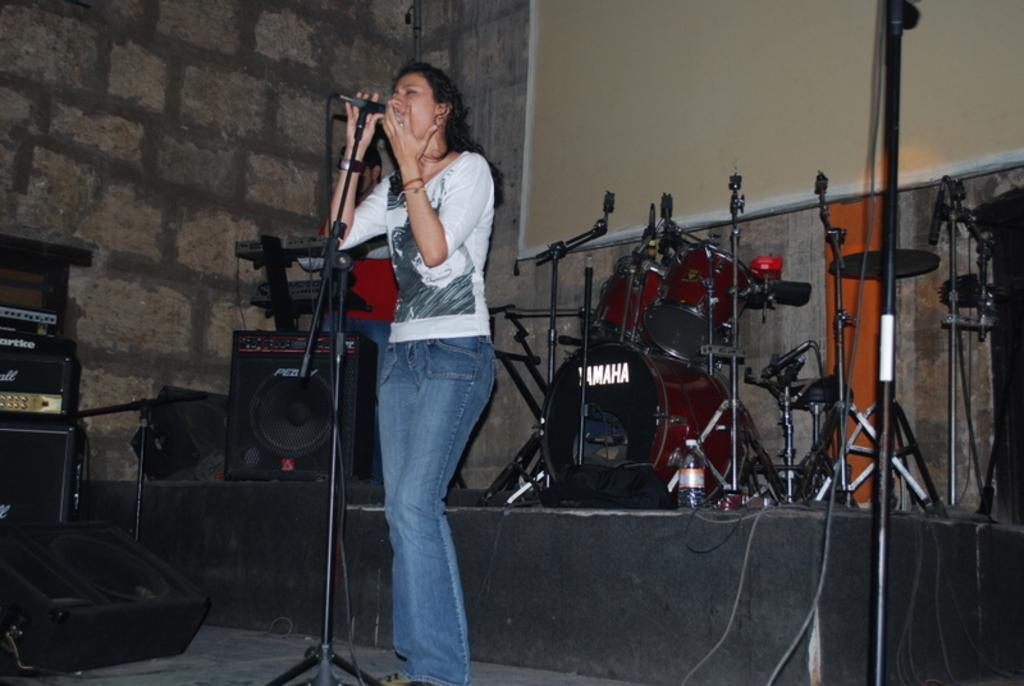In one or two sentences, can you explain what this image depicts? On the background we can see a wall with granites. This is a board. We can see musical instruments on the platform. Near to the platform we can see one woman standing in front of a mike and singing. 